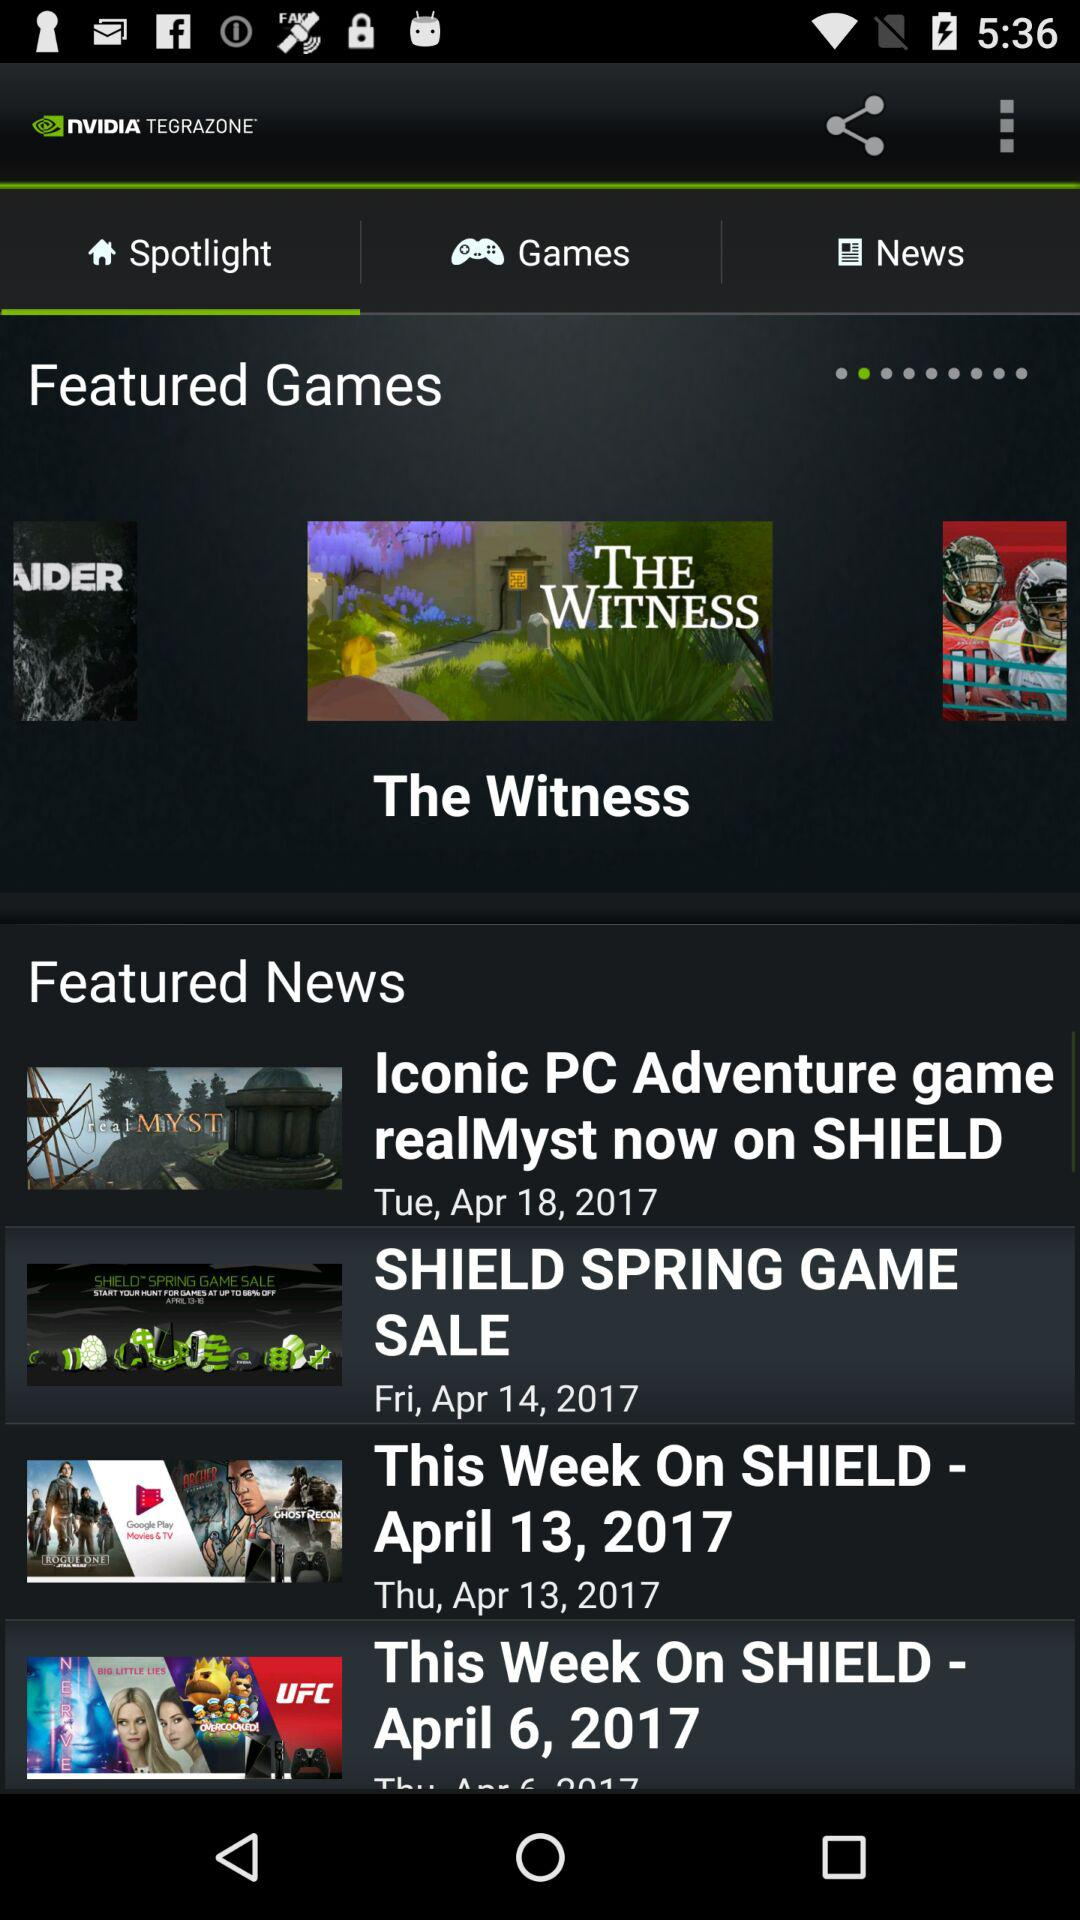Which game is featured? The featured game is "The Witness". 